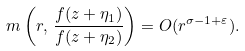Convert formula to latex. <formula><loc_0><loc_0><loc_500><loc_500>m \left ( r , \, \frac { f ( z + \eta _ { 1 } ) } { f ( z + \eta _ { 2 } ) } \right ) = O ( r ^ { \sigma - 1 + \varepsilon } ) .</formula> 